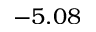Convert formula to latex. <formula><loc_0><loc_0><loc_500><loc_500>- 5 . 0 8</formula> 